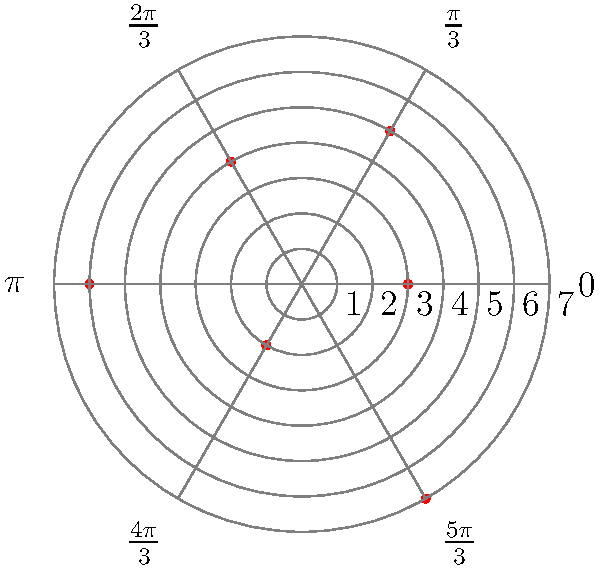As the loyal office manager investigating suspicious financial transactions, you've plotted six transactions on a polar graph. Each transaction is represented by a point $(r, \theta)$, where $r$ is the transaction amount (in thousands of dollars) and $\theta$ is the time of day (in radians, where $0$ represents midnight). Which quadrant of the graph contains the most suspicious transactions, considering that larger amounts and unusual times are more concerning? To determine the most suspicious quadrant, let's analyze the transactions step-by-step:

1. Divide the graph into quadrants:
   - Quadrant I: $0 \leq \theta < \frac{\pi}{2}$
   - Quadrant II: $\frac{\pi}{2} \leq \theta < \pi$
   - Quadrant III: $\pi \leq \theta < \frac{3\pi}{2}$
   - Quadrant IV: $\frac{3\pi}{2} \leq \theta < 2\pi$

2. Identify the transactions in each quadrant:
   - Quadrant I: $(3, 0)$
   - Quadrant II: $(5, \frac{\pi}{3})$, $(4, \frac{2\pi}{3})$
   - Quadrant III: $(6, \pi)$, $(2, \frac{4\pi}{3})$
   - Quadrant IV: $(7, \frac{5\pi}{3})$

3. Assess the suspiciousness of each transaction:
   - Larger amounts are more suspicious
   - Times closer to midnight (0 or $2\pi$ radians) are more unusual

4. Evaluate each quadrant:
   - Quadrant I: One small transaction at midnight
   - Quadrant II: Two moderate transactions at less unusual times
   - Quadrant III: One large and one small transaction at unusual times
   - Quadrant IV: One very large transaction at an unusual time

5. Conclusion:
   Quadrant IV contains the most suspicious transaction, as it has the largest amount ($7,000) and occurs at an unusual time ($\frac{5\pi}{3}$ radians, or 10:00 PM).
Answer: Quadrant IV 